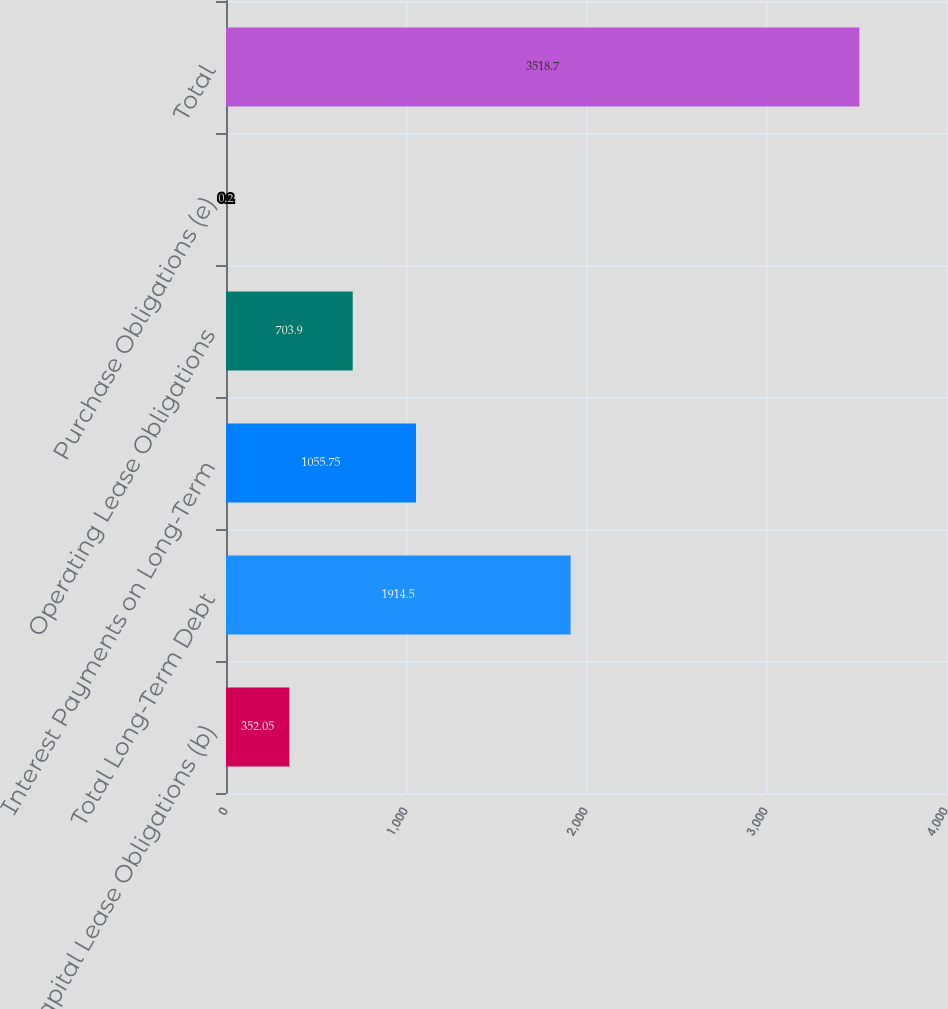<chart> <loc_0><loc_0><loc_500><loc_500><bar_chart><fcel>Capital Lease Obligations (b)<fcel>Total Long-Term Debt<fcel>Interest Payments on Long-Term<fcel>Operating Lease Obligations<fcel>Purchase Obligations (e)<fcel>Total<nl><fcel>352.05<fcel>1914.5<fcel>1055.75<fcel>703.9<fcel>0.2<fcel>3518.7<nl></chart> 